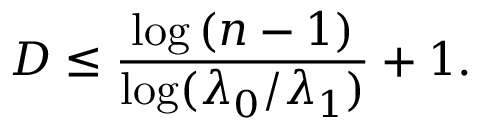Convert formula to latex. <formula><loc_0><loc_0><loc_500><loc_500>D \leq { \frac { \log { ( n - 1 ) } } { \log ( \lambda _ { 0 } / \lambda _ { 1 } ) } } + 1 .</formula> 